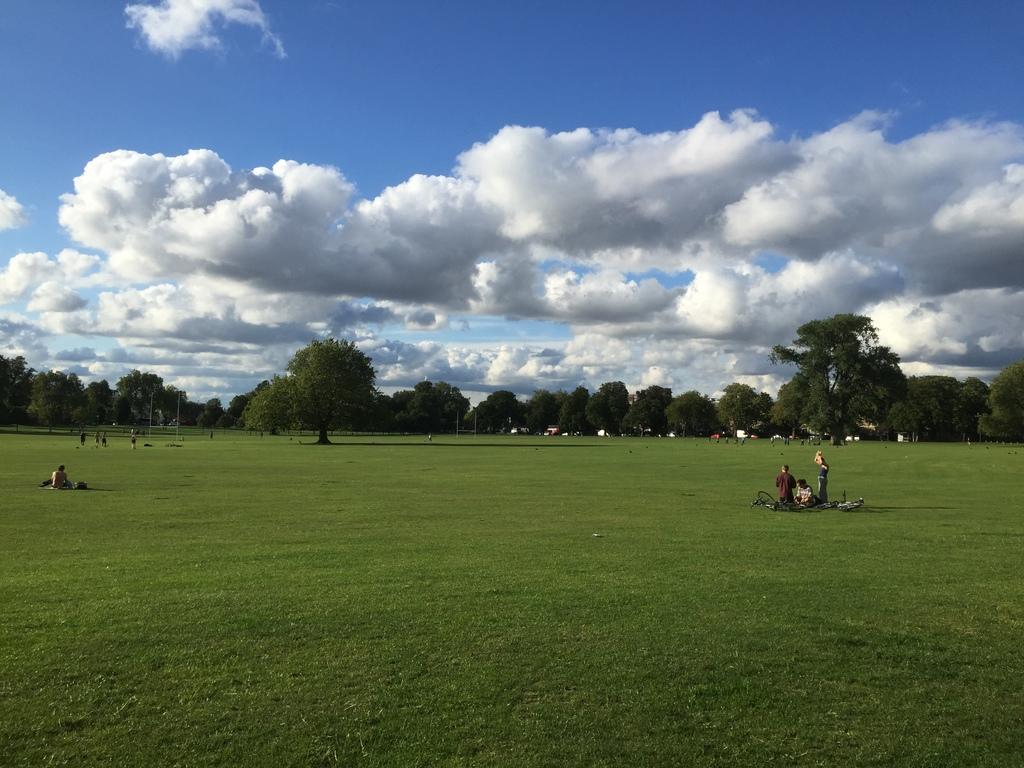Please provide a concise description of this image. In this image we can see two persons sitting on the ground, one person in kneeling position, few people are walking, some people are standing, some objects on the ground, some trees in the background, some grass on the ground, some objects in the background and at the top there is the cloudy sky. 